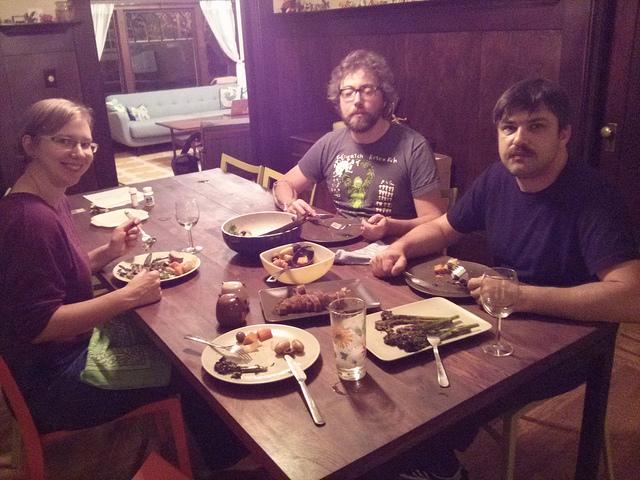Are the people eating?
Quick response, please. Yes. Does everyone in the photo have their eyes open?
Quick response, please. No. How many people are pictured?
Give a very brief answer. 3. 